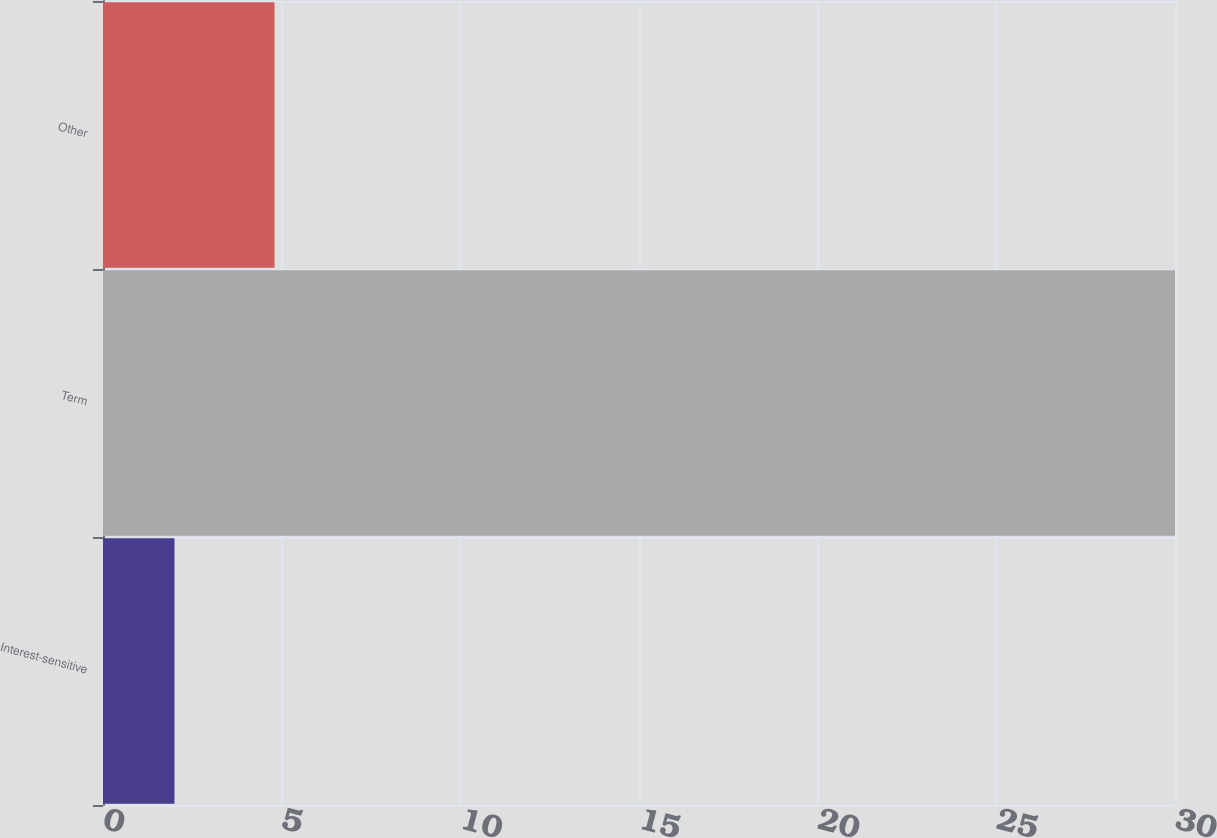<chart> <loc_0><loc_0><loc_500><loc_500><bar_chart><fcel>Interest-sensitive<fcel>Term<fcel>Other<nl><fcel>2<fcel>30<fcel>4.8<nl></chart> 